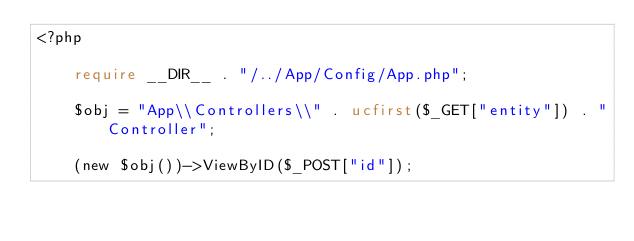Convert code to text. <code><loc_0><loc_0><loc_500><loc_500><_PHP_><?php

    require __DIR__ . "/../App/Config/App.php";

    $obj = "App\\Controllers\\" . ucfirst($_GET["entity"]) . "Controller";

    (new $obj())->ViewByID($_POST["id"]);</code> 